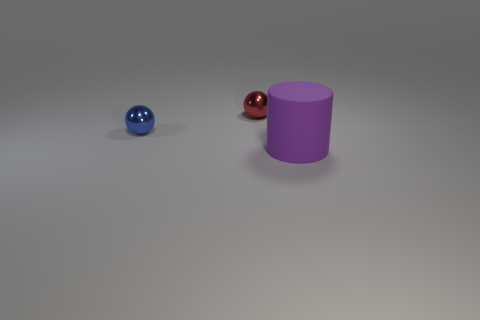Add 2 spheres. How many objects exist? 5 Subtract all spheres. How many objects are left? 1 Add 2 purple matte cylinders. How many purple matte cylinders are left? 3 Add 2 large cylinders. How many large cylinders exist? 3 Subtract 0 yellow spheres. How many objects are left? 3 Subtract all small gray spheres. Subtract all tiny blue shiny spheres. How many objects are left? 2 